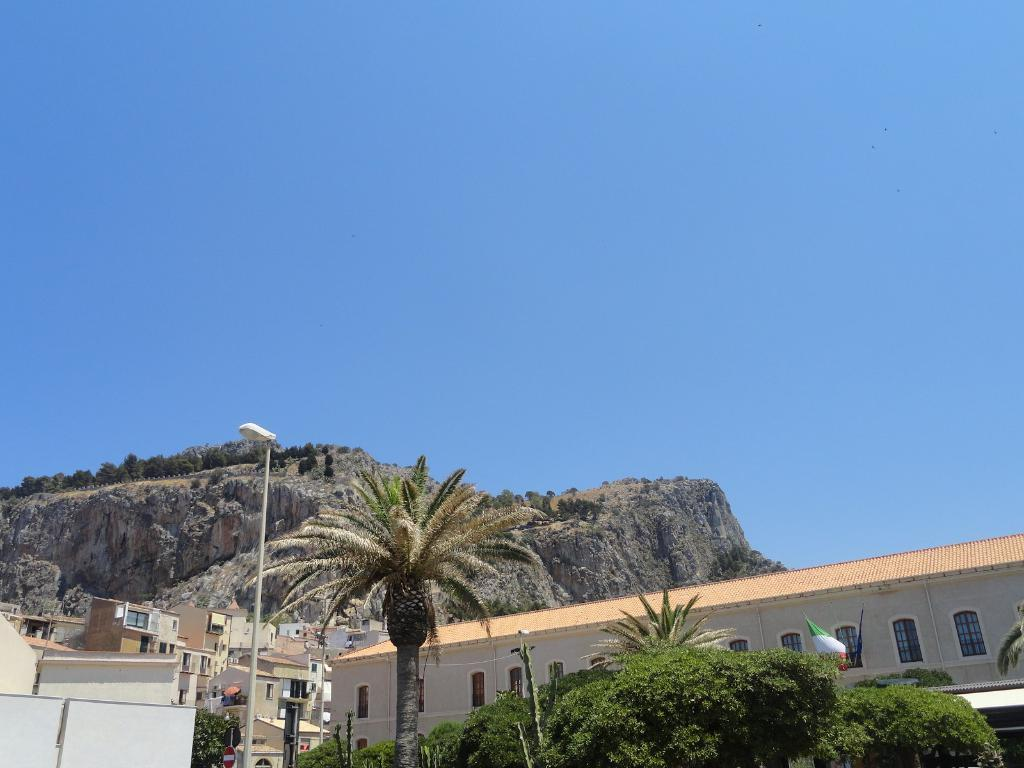What is located at the bottom of the image? There are trees, poles, street lights, a flag, buildings, and a CCTV camera at the bottom of the image. Can you describe the landscape at the top of the image? There are hills at the top of the image, and sky is visible. What type of structures can be seen at the bottom of the image? Buildings are present at the bottom of the image. What is the purpose of the poles at the bottom of the image? The poles at the bottom of the image may be supporting street lights or other infrastructure. Are there any dinosaurs visible in the image? No, there are no dinosaurs present in the image. What type of instrument is being played by the dinosaur in the image? There is no dinosaur or instrument present in the image. 